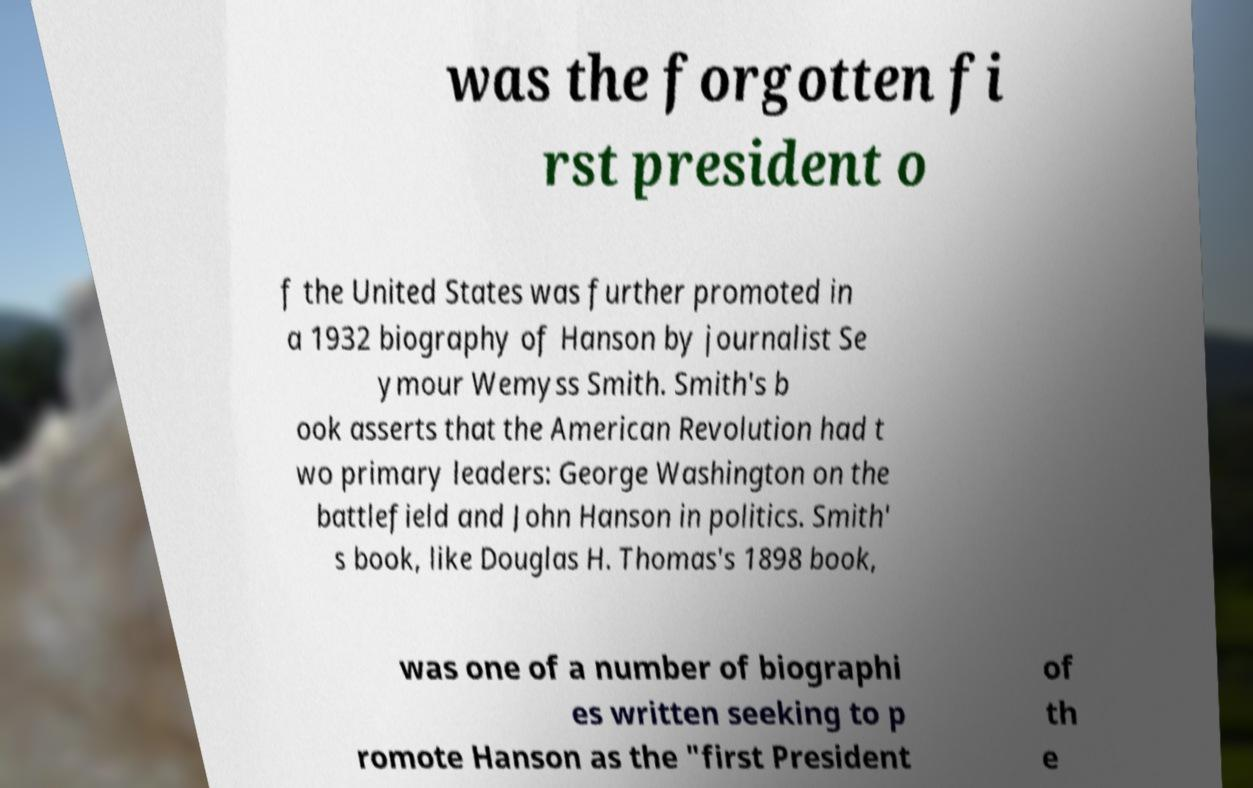Can you accurately transcribe the text from the provided image for me? was the forgotten fi rst president o f the United States was further promoted in a 1932 biography of Hanson by journalist Se ymour Wemyss Smith. Smith's b ook asserts that the American Revolution had t wo primary leaders: George Washington on the battlefield and John Hanson in politics. Smith' s book, like Douglas H. Thomas's 1898 book, was one of a number of biographi es written seeking to p romote Hanson as the "first President of th e 